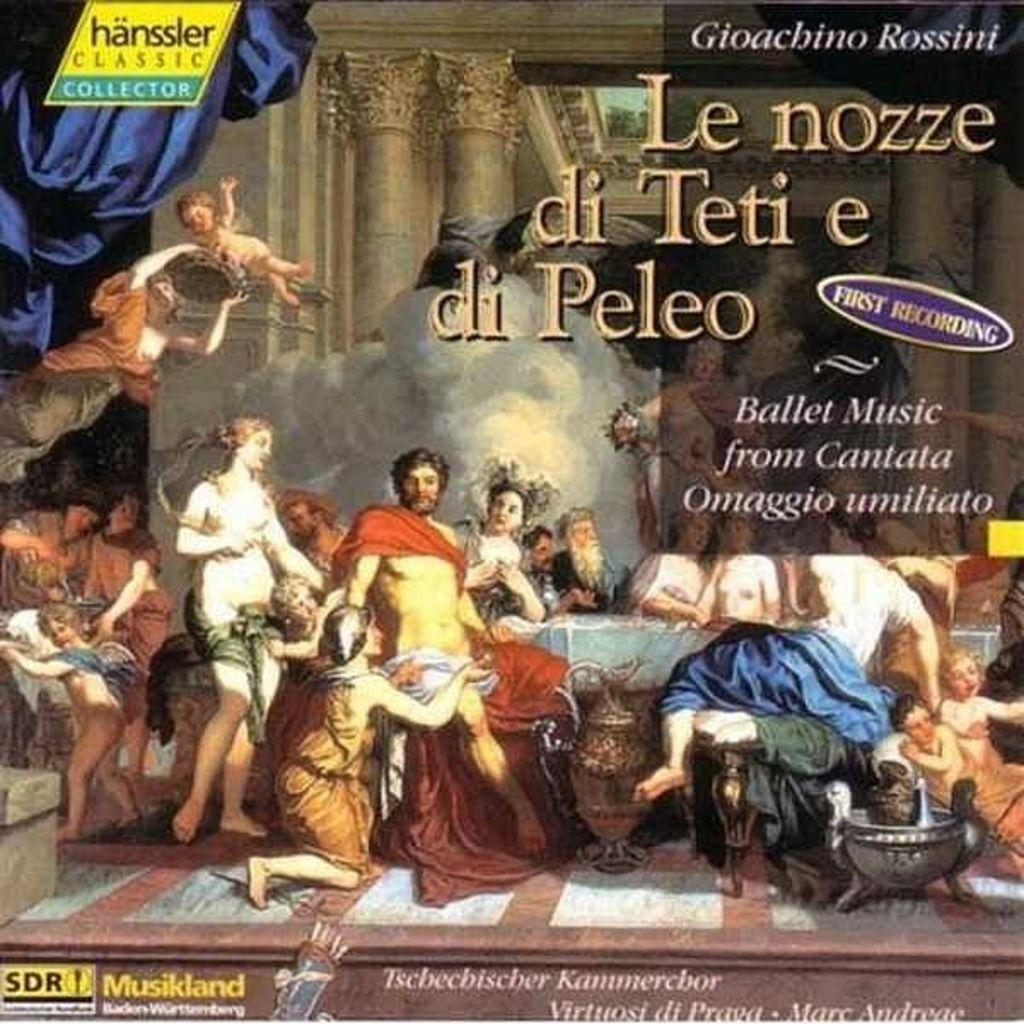What is the main subject of the image? There is a poster in the image. What can be seen on the poster? The poster contains depictions of a person and text. How long does it take for the person on the poster to make a decision in the image? There is no indication of time or decision-making in the image; it only shows a poster with a person and text. 